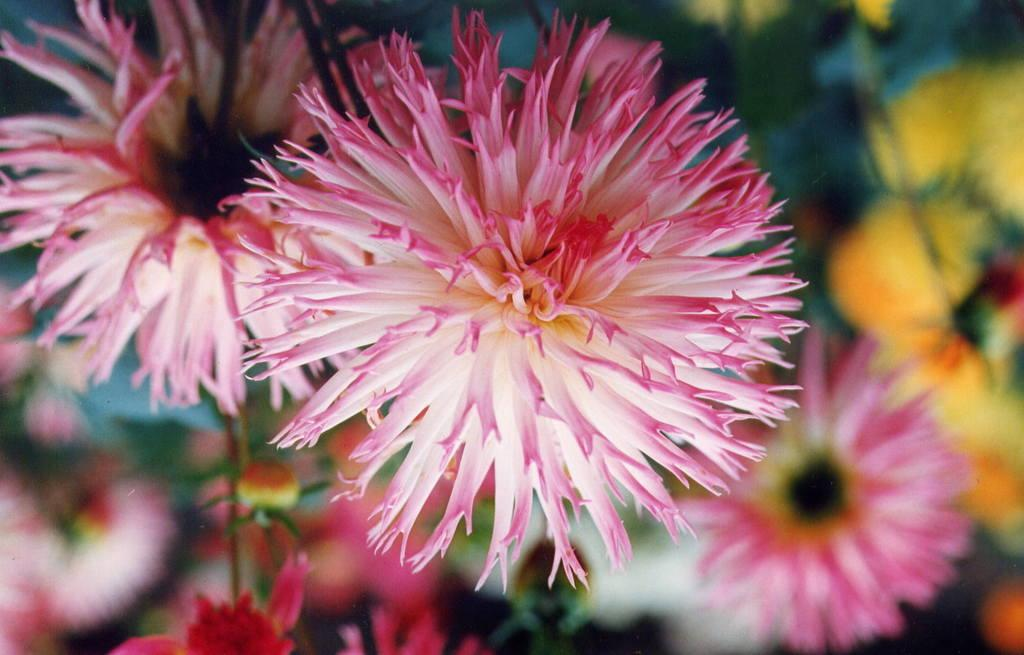What type of plants can be seen in the image? The image contains flowers. How would you describe the appearance of the background in the image? The background of the image is blurred. Can you describe the elements in the background of the image? There are flowers and leaves in the background of the image. What is the current price of the berries in the image? There are no berries present in the image, so it is not possible to determine their price. 